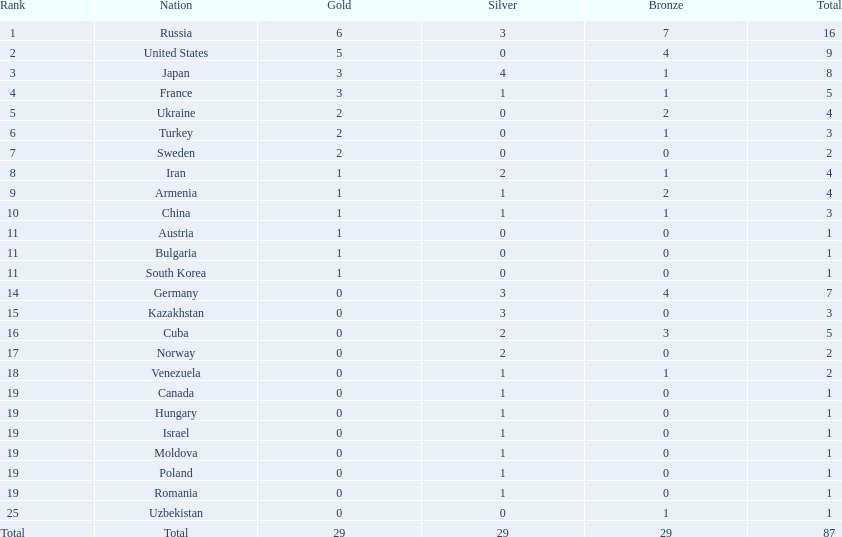What nations were involved in the championships? Russia, United States, Japan, France, Ukraine, Turkey, Sweden, Iran, Armenia, China, Austria, Bulgaria, South Korea, Germany, Kazakhstan, Cuba, Norway, Venezuela, Canada, Hungary, Israel, Moldova, Poland, Romania, Uzbekistan. How many bronze medals were acquired? 7, 4, 1, 1, 2, 1, 0, 1, 2, 1, 0, 0, 0, 4, 0, 3, 0, 1, 0, 0, 0, 0, 0, 0, 1, 29. What's the overall count? 16, 9, 8, 5, 4, 3, 2, 4, 4, 3, 1, 1, 1, 7, 3, 5, 2, 2, 1, 1, 1, 1, 1, 1, 1. And which team earned only one medal - the bronze? Uzbekistan. 